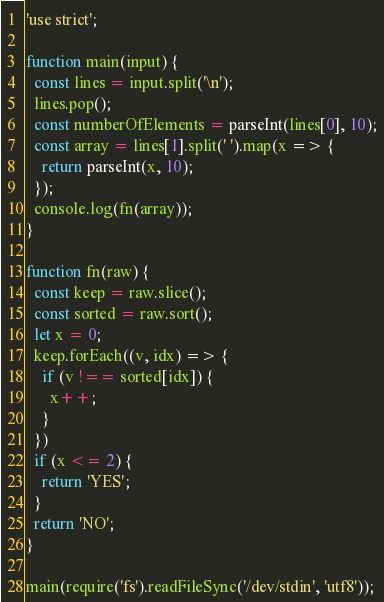<code> <loc_0><loc_0><loc_500><loc_500><_JavaScript_>'use strict';

function main(input) {
  const lines = input.split('\n');
  lines.pop();
  const numberOfElements = parseInt(lines[0], 10);
  const array = lines[1].split(' ').map(x => {
    return parseInt(x, 10);
  });
  console.log(fn(array));
}

function fn(raw) {
  const keep = raw.slice();
  const sorted = raw.sort();
  let x = 0;
  keep.forEach((v, idx) => {
    if (v !== sorted[idx]) {
      x++;
    }
  })
  if (x <= 2) {
    return 'YES';
  }
  return 'NO';
}

main(require('fs').readFileSync('/dev/stdin', 'utf8'));
</code> 